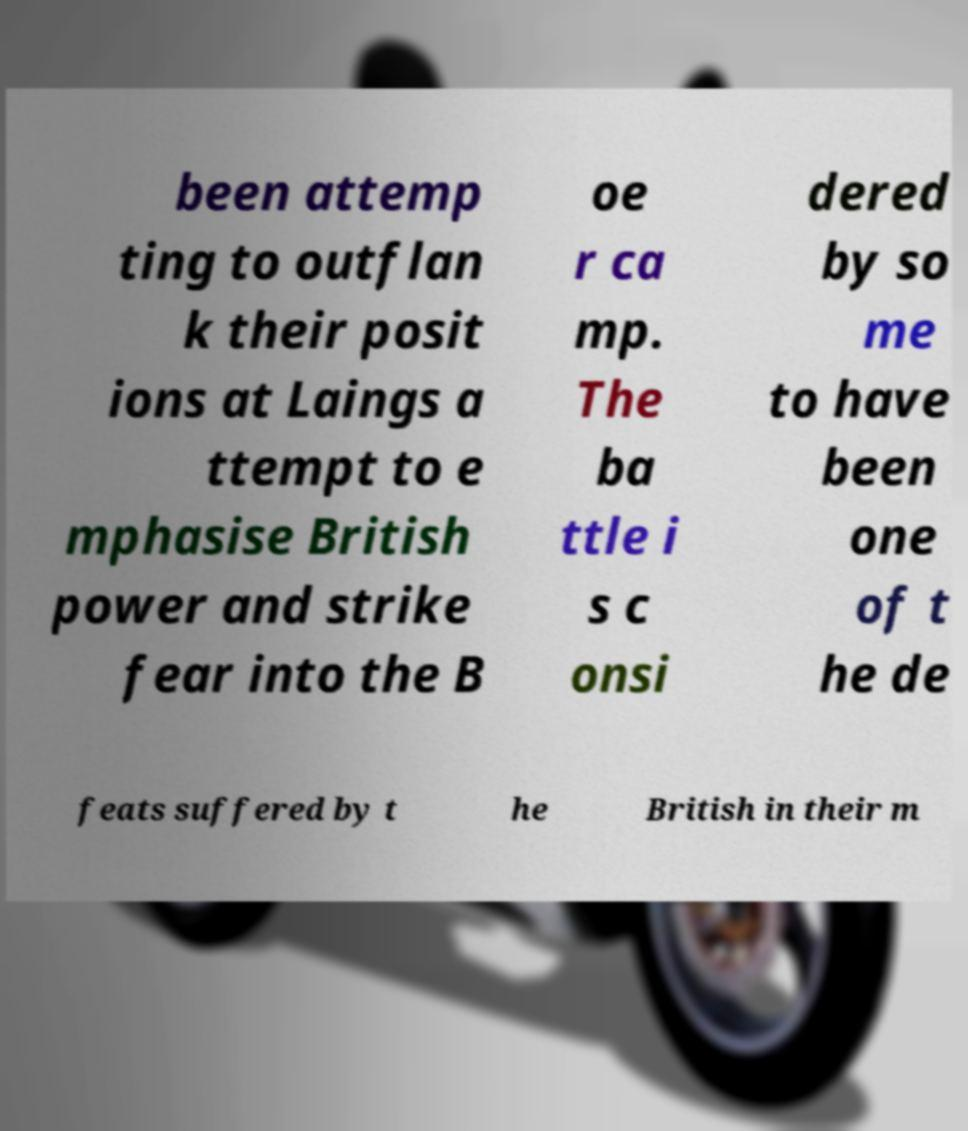Please read and relay the text visible in this image. What does it say? been attemp ting to outflan k their posit ions at Laings a ttempt to e mphasise British power and strike fear into the B oe r ca mp. The ba ttle i s c onsi dered by so me to have been one of t he de feats suffered by t he British in their m 